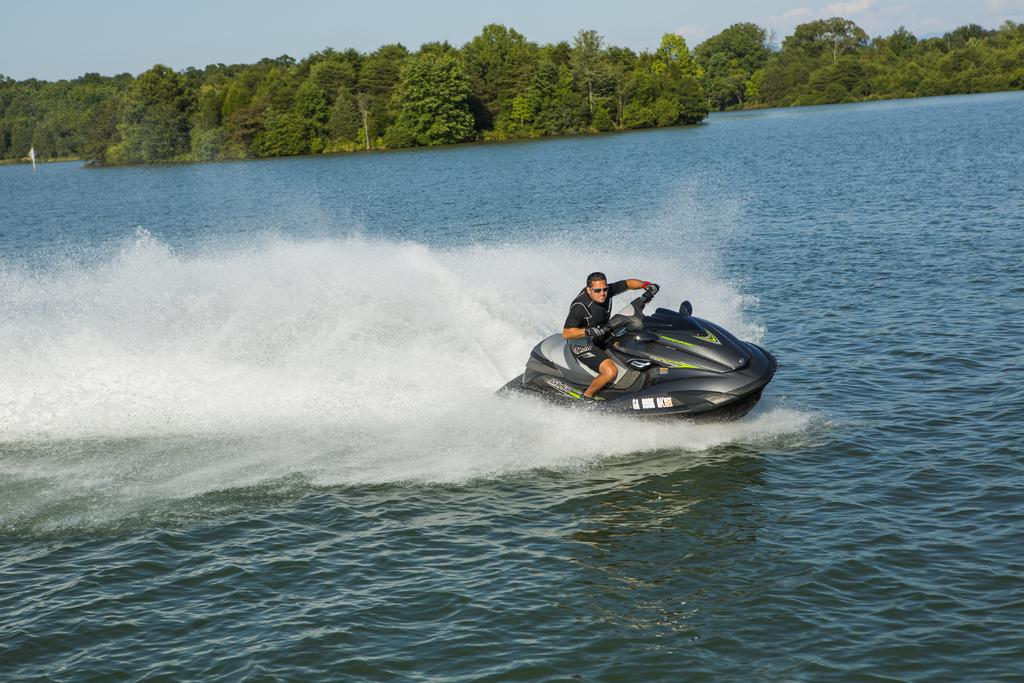What is the person in the image doing? There is a person riding a vehicle in the image. Where is the vehicle located? The vehicle is on a lake in the image. What can be seen in the sky in the image? The sky is visible at the top of the image. What type of vegetation is present in the image? There is a tree in the image. What type of lumber is being used to build the vehicle in the image? There is no lumber visible in the image, and the vehicle is already built. Can you see a hammer being used by the person in the image? There is no hammer present in the image. 